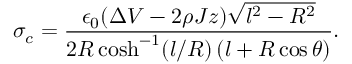<formula> <loc_0><loc_0><loc_500><loc_500>\sigma _ { c } = \frac { \epsilon _ { 0 } ( \Delta V - 2 \rho J z ) \sqrt { l ^ { 2 } - R ^ { 2 } } } { 2 R \cosh ^ { - 1 } ( l / R ) \, ( l + R \cos \theta ) } .</formula> 